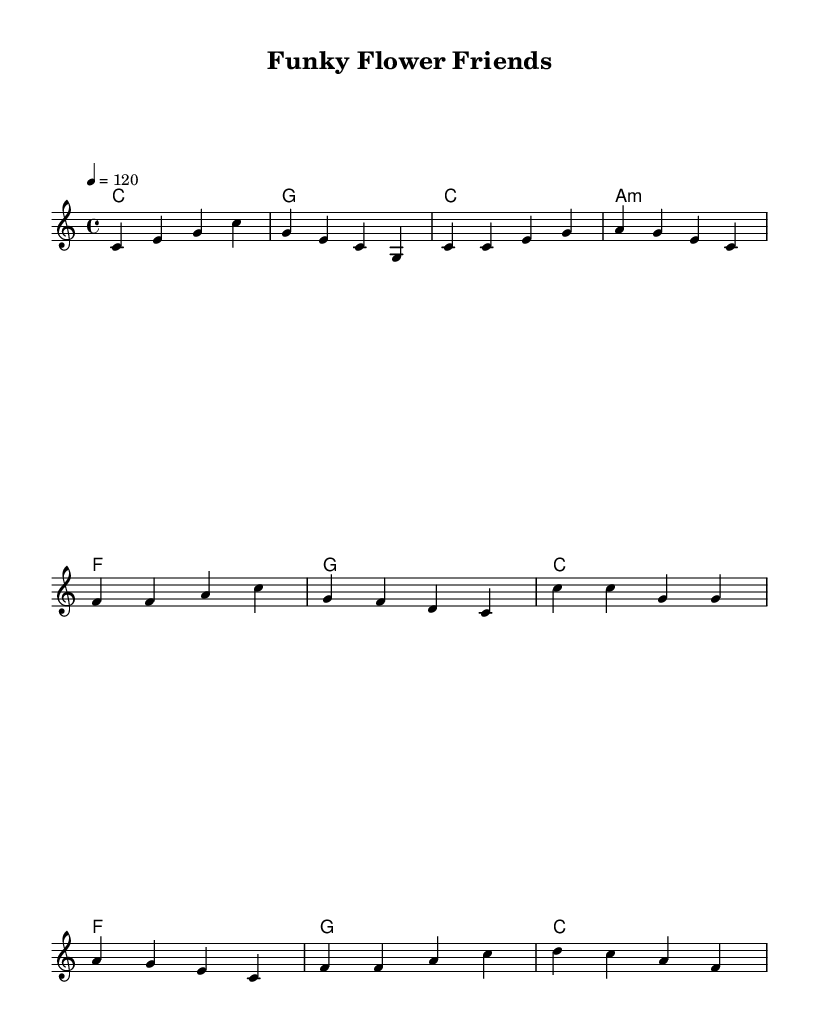What is the key signature of this music? The key signature is located at the beginning of the staff, which indicates that it is in C major. C major has no sharps or flats.
Answer: C major What is the time signature of this music? The time signature appears at the beginning of the score, showing four beats per measure, indicated by 4/4.
Answer: 4/4 What is the tempo marking for this piece? The tempo is indicated at the beginning of the score, stating 4 beats per minute at a speed of 120, meaning the music should be played at a moderate pace.
Answer: 120 How many measures are in the chorus? To count the measures, we look at the section labeled as the chorus and see that there are four measures, as indicated by the bar lines.
Answer: Four What type of chord is used in the second measure of the verse? The second measure of the verse shows the chord indicated is A minor, which contains the notes A, C, and E.
Answer: A minor What is the main theme of the lyrics in the verse? The lyrics in the verse focus on planting seeds, nurturing them with water and sunlight, and the growth of plants, emphasizing their amazing qualities.
Answer: Growth of plants What rhythm pattern is used in the chorus? In the chorus, the rhythmic pattern consists mainly of quarter notes, making it upbeat and vibrant, typical of Funk music, which often emphasizes strong rhythms.
Answer: Quarter notes 